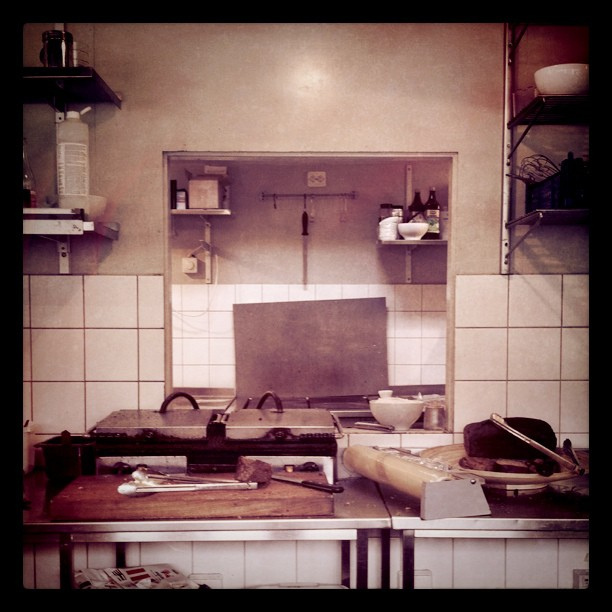<image>Where is the mirror located? It is ambiguous where the mirror is located as it may not be in the image. However, if it is, it could be on the wall or over a sink. Where is the mirror located? The mirror is located on the wall. 